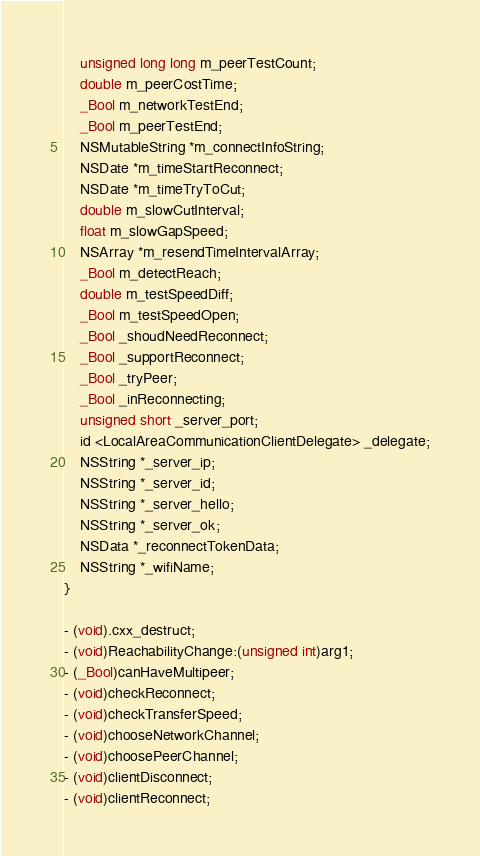Convert code to text. <code><loc_0><loc_0><loc_500><loc_500><_C_>    unsigned long long m_peerTestCount;
    double m_peerCostTime;
    _Bool m_networkTestEnd;
    _Bool m_peerTestEnd;
    NSMutableString *m_connectInfoString;
    NSDate *m_timeStartReconnect;
    NSDate *m_timeTryToCut;
    double m_slowCutInterval;
    float m_slowGapSpeed;
    NSArray *m_resendTimeIntervalArray;
    _Bool m_detectReach;
    double m_testSpeedDiff;
    _Bool m_testSpeedOpen;
    _Bool _shoudNeedReconnect;
    _Bool _supportReconnect;
    _Bool _tryPeer;
    _Bool _inReconnecting;
    unsigned short _server_port;
    id <LocalAreaCommunicationClientDelegate> _delegate;
    NSString *_server_ip;
    NSString *_server_id;
    NSString *_server_hello;
    NSString *_server_ok;
    NSData *_reconnectTokenData;
    NSString *_wifiName;
}

- (void).cxx_destruct;
- (void)ReachabilityChange:(unsigned int)arg1;
- (_Bool)canHaveMultipeer;
- (void)checkReconnect;
- (void)checkTransferSpeed;
- (void)chooseNetworkChannel;
- (void)choosePeerChannel;
- (void)clientDisconnect;
- (void)clientReconnect;</code> 